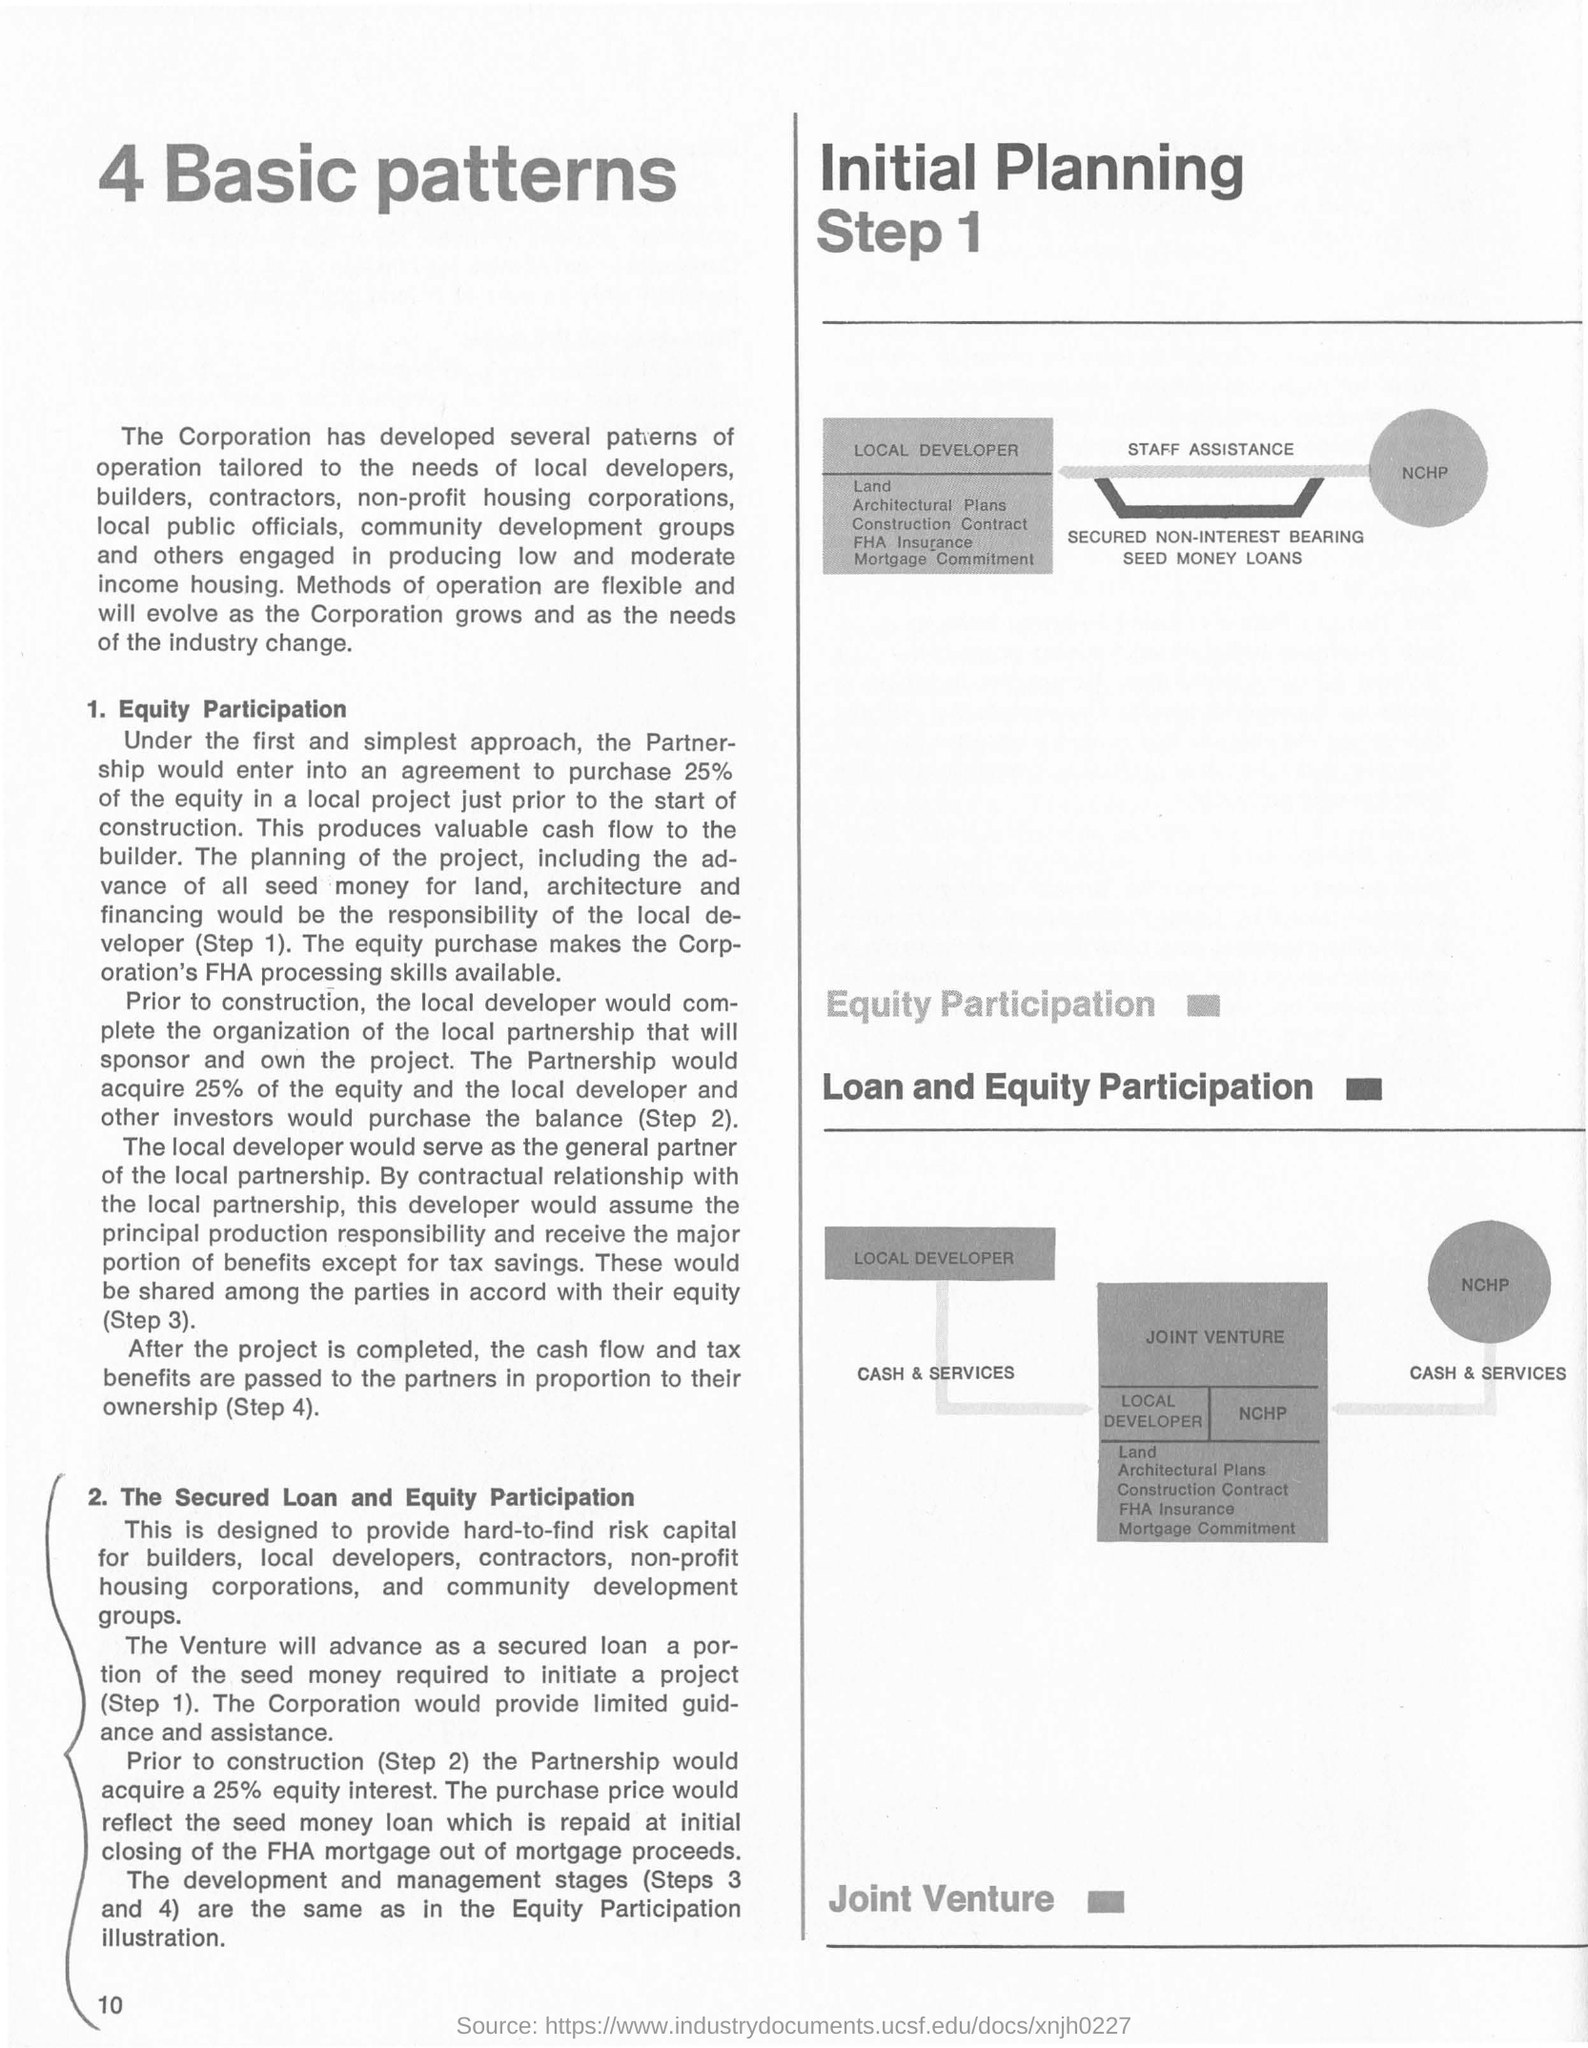How many basic patterns mentioned at the top right side of the page?
Your answer should be compact. 4. What is the first subtitle under the the title of '4 basic patterns'?
Your response must be concise. 1. Equity Participation. 